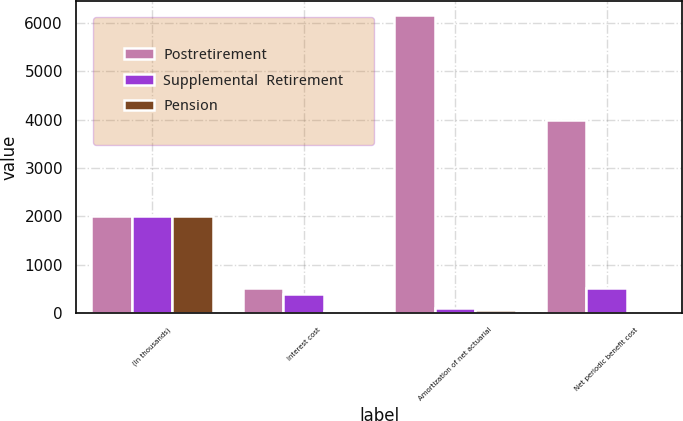Convert chart. <chart><loc_0><loc_0><loc_500><loc_500><stacked_bar_chart><ecel><fcel>(In thousands)<fcel>Interest cost<fcel>Amortization of net actuarial<fcel>Net periodic benefit cost<nl><fcel>Postretirement<fcel>2016<fcel>519<fcel>6149<fcel>3982<nl><fcel>Supplemental  Retirement<fcel>2016<fcel>402<fcel>117<fcel>519<nl><fcel>Pension<fcel>2016<fcel>38<fcel>67<fcel>8<nl></chart> 